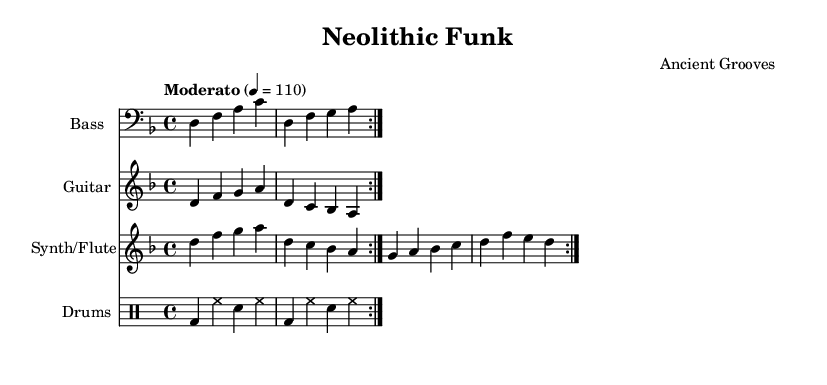What is the key signature of this music? The key signature indicates that this piece is in D minor, which has one flat (B flat). This can be identified by looking for the flat sign written at the beginning of the staff lines.
Answer: D minor What is the time signature of this music? The time signature is found at the beginning of the score it shows a fraction indicating the number of beats in each measure. The 4/4 time signature means there are four beats per measure.
Answer: 4/4 What is the tempo marking? The tempo marking is noted at the beginning and specifies the speed of the piece, which is indicated to be "Moderato" at a pace of 110 beats per minute. This is identified by the tempo notation shown above the staff.
Answer: Moderato, 110 How many measures are in the bass line? By counting the number of measure bars in the bass line section, we find that there are four full measures since each measure is separated by a vertical line.
Answer: 4 What type of instrumentation is used in this piece? The instrumentation can be determined by looking at the names of the individual staves. The piece features Bass, Guitar, Synth/Flute, and Drums. This is evident from the instrument names displayed at the beginning of each staff.
Answer: Bass, Guitar, Synth/Flute, Drums What rhythmic pattern is used in the drum section? The rhythmic pattern in the drum section can be analyzed by examining the drum notation. The pattern consists of bass drums, hi-hat, and snare drum played in a repeated cycle, with a specific sequence identified.
Answer: Bass drum, hi-hat, snare drum 